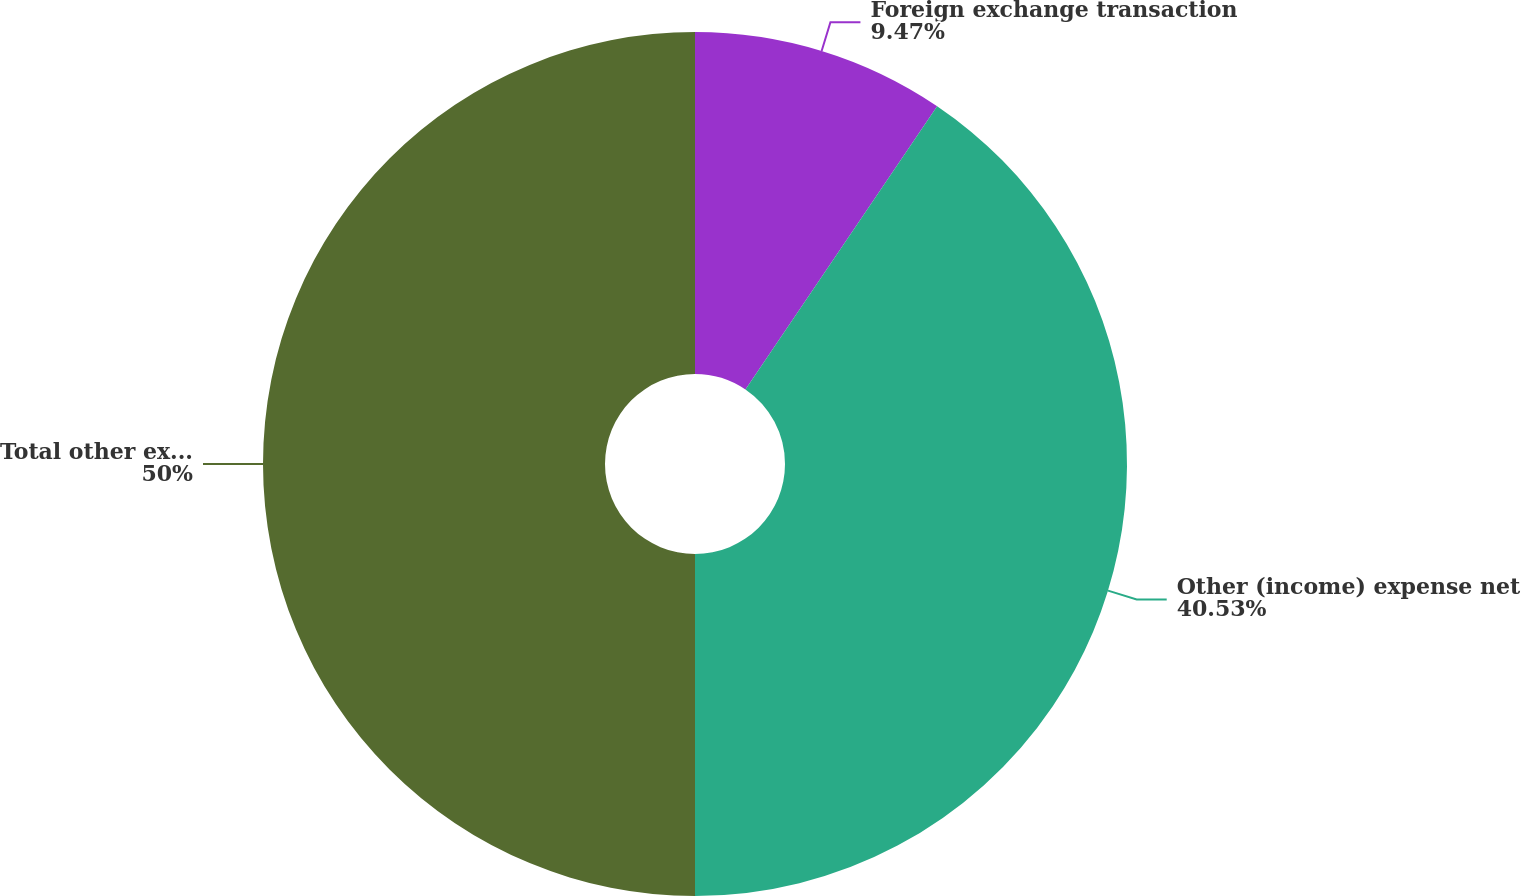Convert chart to OTSL. <chart><loc_0><loc_0><loc_500><loc_500><pie_chart><fcel>Foreign exchange transaction<fcel>Other (income) expense net<fcel>Total other expense (income)<nl><fcel>9.47%<fcel>40.53%<fcel>50.0%<nl></chart> 